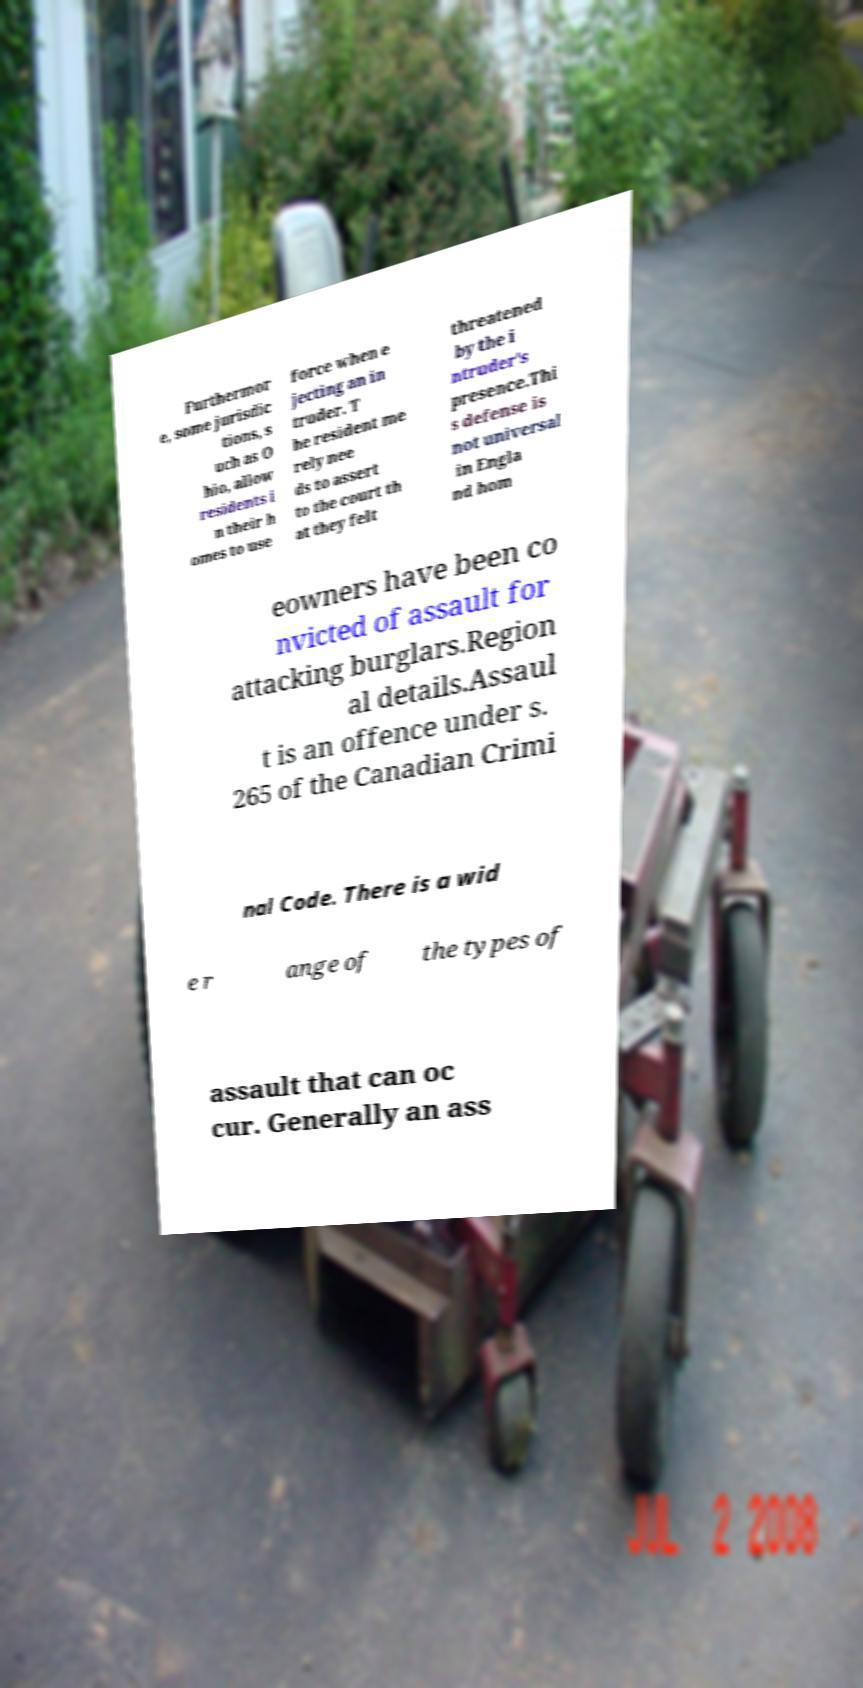There's text embedded in this image that I need extracted. Can you transcribe it verbatim? Furthermor e, some jurisdic tions, s uch as O hio, allow residents i n their h omes to use force when e jecting an in truder. T he resident me rely nee ds to assert to the court th at they felt threatened by the i ntruder's presence.Thi s defense is not universal in Engla nd hom eowners have been co nvicted of assault for attacking burglars.Region al details.Assaul t is an offence under s. 265 of the Canadian Crimi nal Code. There is a wid e r ange of the types of assault that can oc cur. Generally an ass 